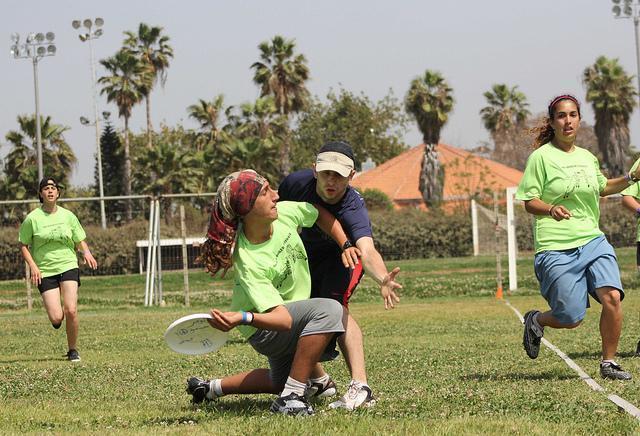The players are wearing the same shirts because they play in a what?
Indicate the correct response and explain using: 'Answer: answer
Rationale: rationale.'
Options: Family reunion, league, school, random match. Answer: league.
Rationale: The players are part of a team. 